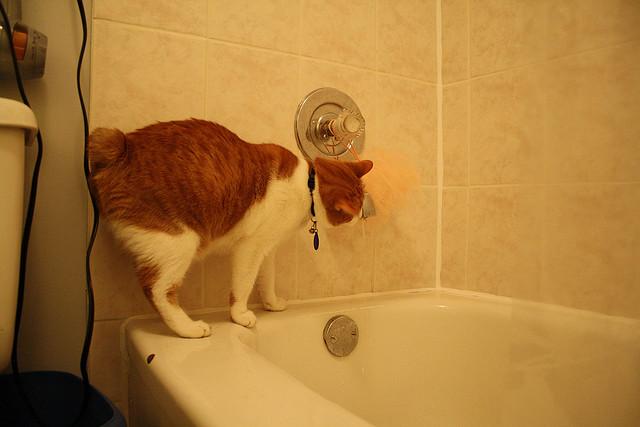Is this cat drinking from the dripping water?
Concise answer only. Yes. What is the lightest color of fur appearing on the cat?
Answer briefly. White. Is the cat getting wet?
Quick response, please. No. Does the cat have a shorter than average tail?
Be succinct. Yes. 